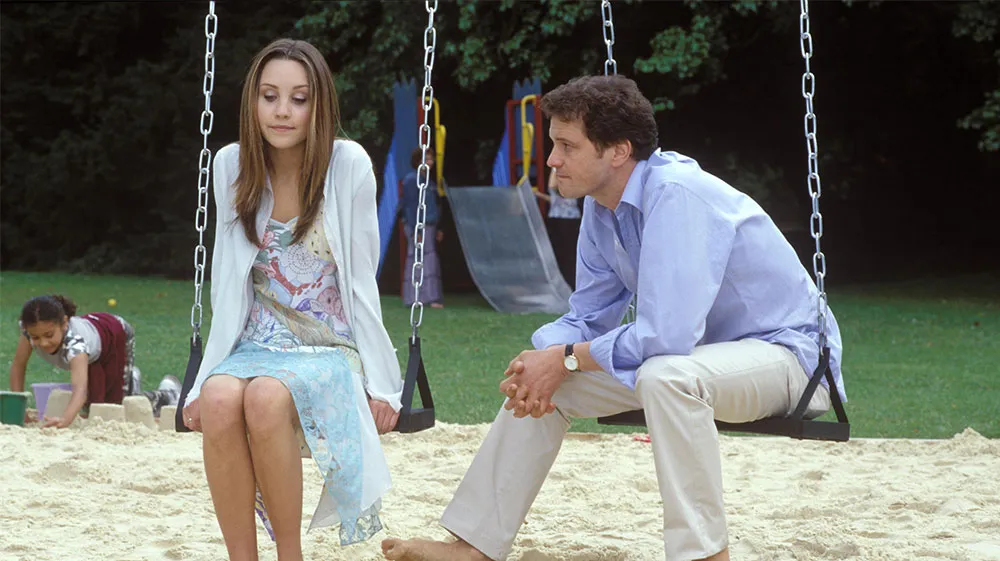What is the significance of the background elements in this image? The background elements play a crucial role in setting the scene and adding context to the characters' interaction. The playground equipment and children playing suggest a family-friendly environment, adding a sense of warmth and community. The green trees and open space contribute to a peaceful, serene atmosphere, which contrasts with the possibly serious conversation between the individuals. This juxtaposition emphasizes the private nature of their discussion amidst the public, carefree environment of the park. It highlights the layers of human experience, where personal moments unfold in shared public spaces. Imagine the two individuals are reminiscing about their childhood. What could they be talking about? The two individuals are nostalgically reminiscing about their childhood days spent at this very park. The woman recalls how they used to race each other to the swings, laughing breathlessly, while the man fondly remembers building elaborate sandcastles in the sandbox. They talk about the imaginative games they played, how they used to pretend to be explorers in a jungle made up of the park's trees. Their conversation is filled with laughter and 'remember-when' stories, each memory building a bridge back to their carefree days. The woman smiles as she recalls a particular summer when they spent almost every day at the park, savoring ice creams and making new friends. The man chuckles as he recounts their secret hideout behind the old oak tree, which became their headquarters for countless adventures. What if the swings and the playground had a hidden significance? Write a fantastical story based on this image. In an enchanted twist, the playground in the image is actually a gateway to a magical realm. Long ago, the swings were enchanted by a benevolent wizard who wished to grant access to a world filled with mythical creatures and ancient forests. Only those with pure hearts and a deep sense of wonder can activate the portal by swinging in a specific rhythm. The two individuals in the image are chosen guardians of this secret. As they swing, the rhythmic creak of the chains gradually gives way to the sounds of a mystical forest coming alive with chirping fairies and whispering trees. Their serious conversation is about the recent disturbances in this magical world—a rogue sorcerer seeking the enchanted artifacts hidden within the playground. Their mission is to protect these artifacts and maintain the balance between the realms. The children playing in the background, oblivious to the hidden portal, add a poignant touch, as the guardians work tirelessly to keep the magic hidden and the children safe. Describe a realistic and short scenario where the man is giving advice to the woman. The man is offering advice to the woman about balancing her work and personal life. He's suggesting she take time for herself and not to be too hard on herself when things don't go as planned. His tone is supportive and kind, encouraging her to find small ways to relax and rejuvenate amid her busy schedule. Describe a realistic and long scenario where the man is expressing his support for the woman's recent life decision. The man is expressing heartfelt support for the woman's recent decision to change her career path. They've met at the park to discuss her choice to leave a stable but unfulfilling job and pursue her passion for art. He listens attentively as she explains her mixed feelings of excitement and uncertainty about starting her own art studio. The man reassures her, acknowledging the courage it takes to follow one's passion. He reminds her of her immense talent and the joy her art brings to others, emphasizing how important it is to feel fulfilled in one's work. He shares stories of people he knows who've made similar leaps and found great satisfaction, despite initial challenges. His supportive words and the real-life examples he offers help alleviate her doubts, making her feel more confident and reassured about her decision. Their discussion also touches on practical aspects, such as financial planning and networking within the art community, further demonstrating his commitment to her success. The serene park setting provides a calming backdrop, allowing them to delve deep into this crucial topic without distractions. 